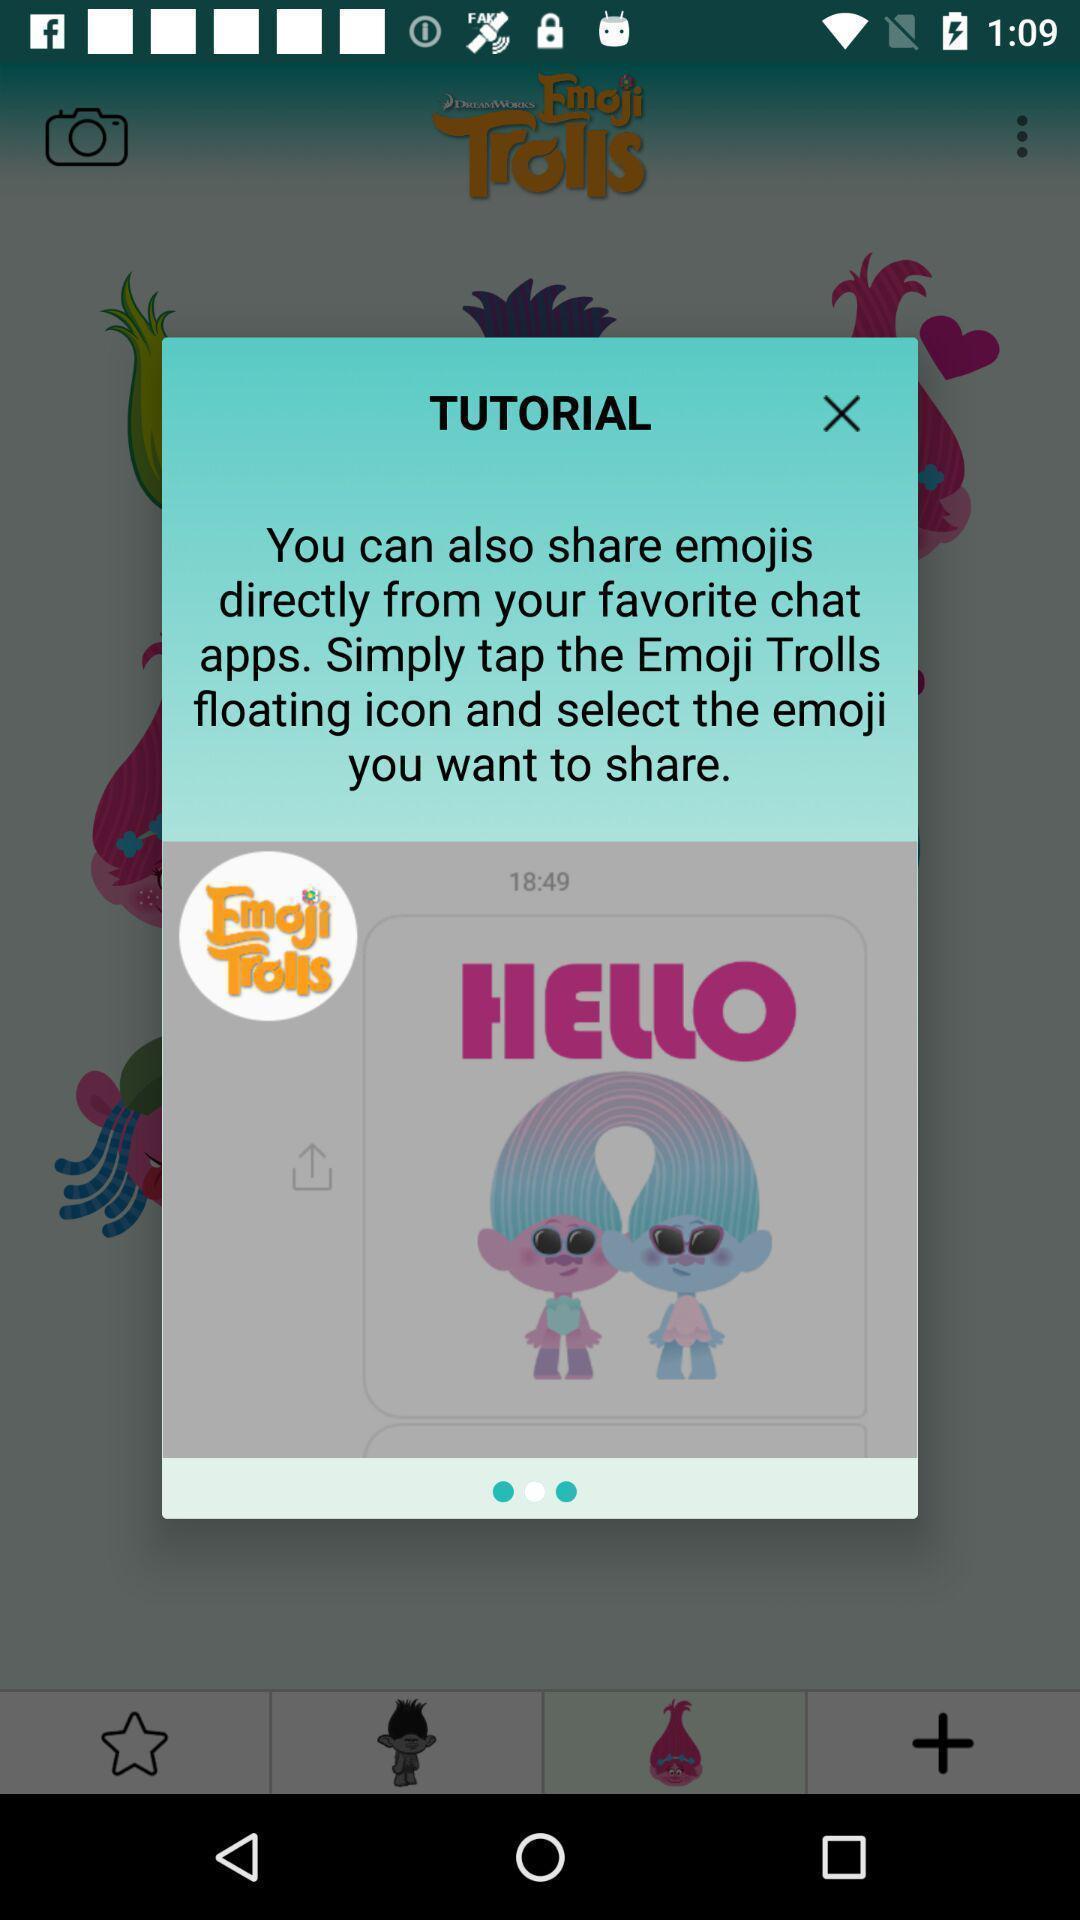Give me a summary of this screen capture. Push up showing emojis details. 